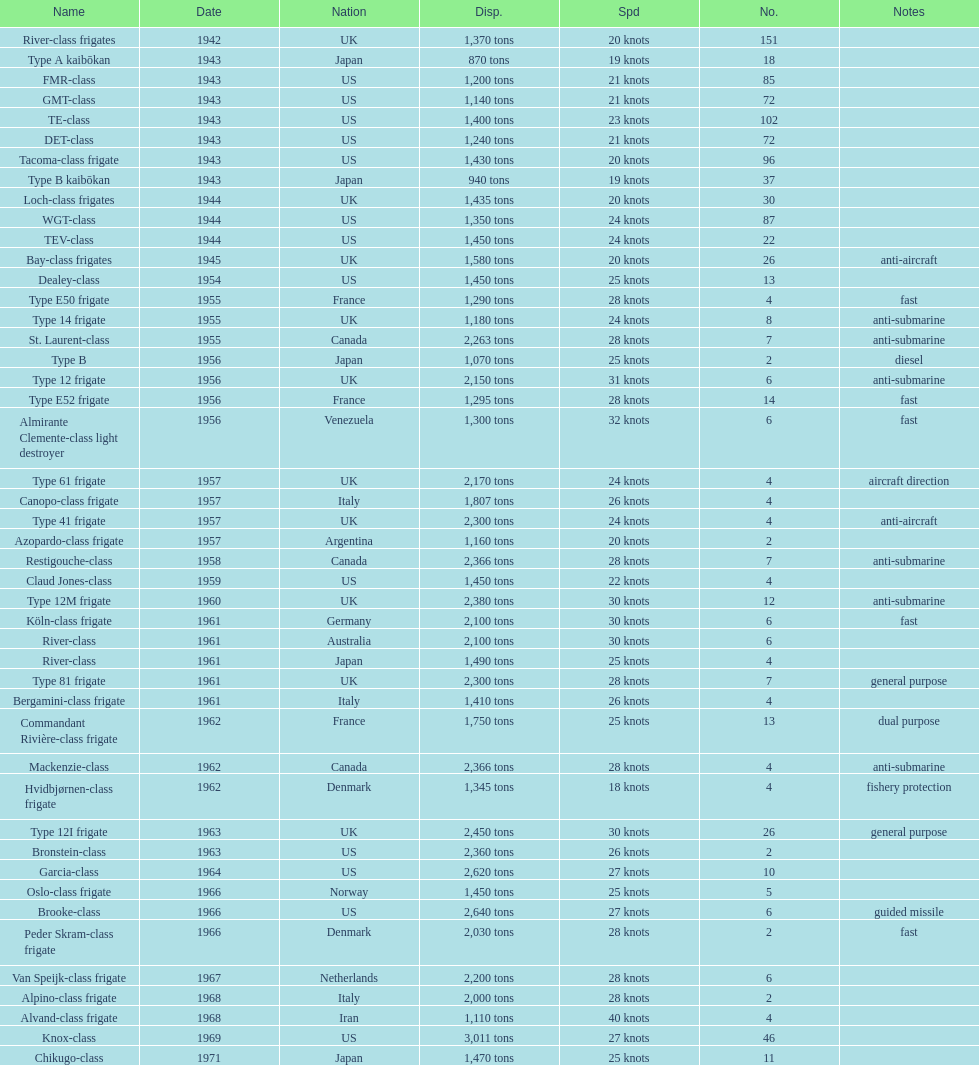What is the difference in speed for the gmt-class and the te-class? 2 knots. 